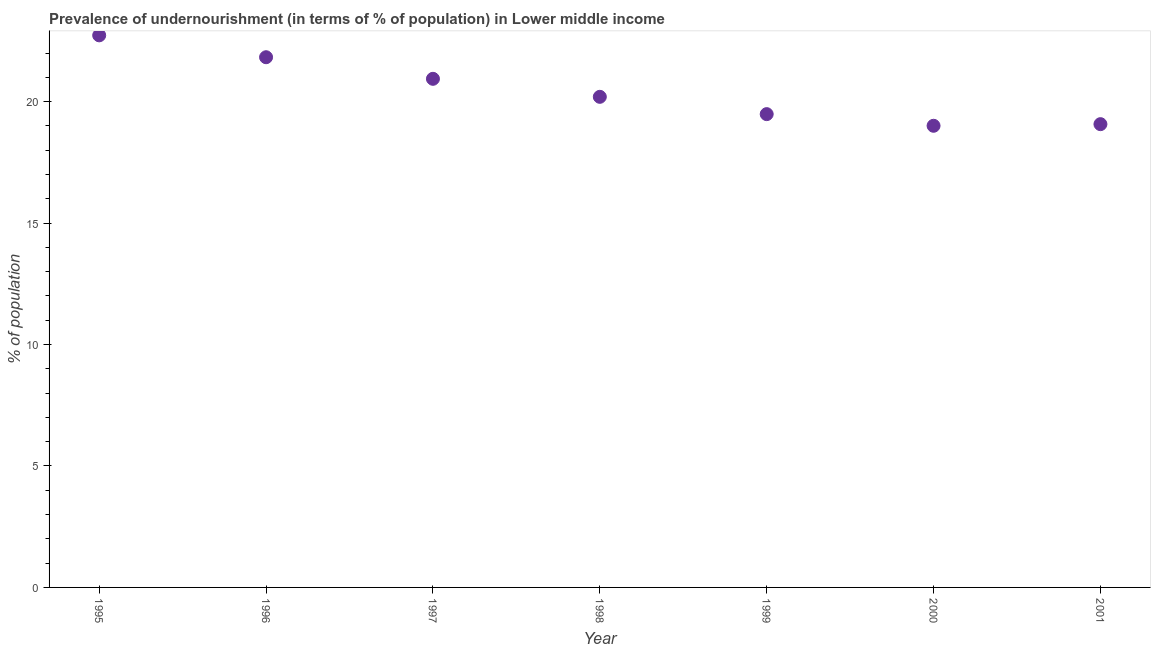What is the percentage of undernourished population in 1999?
Provide a succinct answer. 19.48. Across all years, what is the maximum percentage of undernourished population?
Your answer should be compact. 22.73. Across all years, what is the minimum percentage of undernourished population?
Keep it short and to the point. 19. In which year was the percentage of undernourished population maximum?
Offer a terse response. 1995. What is the sum of the percentage of undernourished population?
Ensure brevity in your answer.  143.25. What is the difference between the percentage of undernourished population in 1995 and 2000?
Your answer should be compact. 3.72. What is the average percentage of undernourished population per year?
Provide a short and direct response. 20.46. What is the median percentage of undernourished population?
Your answer should be very brief. 20.2. In how many years, is the percentage of undernourished population greater than 10 %?
Your response must be concise. 7. Do a majority of the years between 1998 and 2001 (inclusive) have percentage of undernourished population greater than 18 %?
Provide a succinct answer. Yes. What is the ratio of the percentage of undernourished population in 1996 to that in 2000?
Your answer should be very brief. 1.15. What is the difference between the highest and the second highest percentage of undernourished population?
Your answer should be very brief. 0.9. What is the difference between the highest and the lowest percentage of undernourished population?
Your answer should be very brief. 3.72. In how many years, is the percentage of undernourished population greater than the average percentage of undernourished population taken over all years?
Provide a short and direct response. 3. Does the percentage of undernourished population monotonically increase over the years?
Your response must be concise. No. Are the values on the major ticks of Y-axis written in scientific E-notation?
Provide a short and direct response. No. Does the graph contain grids?
Your answer should be very brief. No. What is the title of the graph?
Ensure brevity in your answer.  Prevalence of undernourishment (in terms of % of population) in Lower middle income. What is the label or title of the X-axis?
Your answer should be very brief. Year. What is the label or title of the Y-axis?
Offer a terse response. % of population. What is the % of population in 1995?
Keep it short and to the point. 22.73. What is the % of population in 1996?
Your answer should be compact. 21.83. What is the % of population in 1997?
Offer a terse response. 20.94. What is the % of population in 1998?
Ensure brevity in your answer.  20.2. What is the % of population in 1999?
Make the answer very short. 19.48. What is the % of population in 2000?
Make the answer very short. 19. What is the % of population in 2001?
Ensure brevity in your answer.  19.07. What is the difference between the % of population in 1995 and 1996?
Offer a terse response. 0.9. What is the difference between the % of population in 1995 and 1997?
Make the answer very short. 1.79. What is the difference between the % of population in 1995 and 1998?
Your answer should be very brief. 2.53. What is the difference between the % of population in 1995 and 1999?
Provide a succinct answer. 3.24. What is the difference between the % of population in 1995 and 2000?
Ensure brevity in your answer.  3.72. What is the difference between the % of population in 1995 and 2001?
Offer a terse response. 3.66. What is the difference between the % of population in 1996 and 1997?
Your response must be concise. 0.89. What is the difference between the % of population in 1996 and 1998?
Give a very brief answer. 1.63. What is the difference between the % of population in 1996 and 1999?
Ensure brevity in your answer.  2.34. What is the difference between the % of population in 1996 and 2000?
Offer a very short reply. 2.82. What is the difference between the % of population in 1996 and 2001?
Offer a terse response. 2.76. What is the difference between the % of population in 1997 and 1998?
Ensure brevity in your answer.  0.74. What is the difference between the % of population in 1997 and 1999?
Give a very brief answer. 1.45. What is the difference between the % of population in 1997 and 2000?
Your answer should be very brief. 1.93. What is the difference between the % of population in 1997 and 2001?
Ensure brevity in your answer.  1.87. What is the difference between the % of population in 1998 and 1999?
Your answer should be compact. 0.71. What is the difference between the % of population in 1998 and 2000?
Offer a very short reply. 1.19. What is the difference between the % of population in 1998 and 2001?
Ensure brevity in your answer.  1.13. What is the difference between the % of population in 1999 and 2000?
Offer a terse response. 0.48. What is the difference between the % of population in 1999 and 2001?
Your answer should be compact. 0.41. What is the difference between the % of population in 2000 and 2001?
Your answer should be compact. -0.07. What is the ratio of the % of population in 1995 to that in 1996?
Make the answer very short. 1.04. What is the ratio of the % of population in 1995 to that in 1997?
Your answer should be compact. 1.08. What is the ratio of the % of population in 1995 to that in 1999?
Your answer should be very brief. 1.17. What is the ratio of the % of population in 1995 to that in 2000?
Give a very brief answer. 1.2. What is the ratio of the % of population in 1995 to that in 2001?
Ensure brevity in your answer.  1.19. What is the ratio of the % of population in 1996 to that in 1997?
Your answer should be very brief. 1.04. What is the ratio of the % of population in 1996 to that in 1998?
Your answer should be compact. 1.08. What is the ratio of the % of population in 1996 to that in 1999?
Provide a short and direct response. 1.12. What is the ratio of the % of population in 1996 to that in 2000?
Provide a succinct answer. 1.15. What is the ratio of the % of population in 1996 to that in 2001?
Ensure brevity in your answer.  1.14. What is the ratio of the % of population in 1997 to that in 1999?
Provide a short and direct response. 1.07. What is the ratio of the % of population in 1997 to that in 2000?
Offer a very short reply. 1.1. What is the ratio of the % of population in 1997 to that in 2001?
Offer a terse response. 1.1. What is the ratio of the % of population in 1998 to that in 2000?
Make the answer very short. 1.06. What is the ratio of the % of population in 1998 to that in 2001?
Your answer should be very brief. 1.06. What is the ratio of the % of population in 2000 to that in 2001?
Your answer should be very brief. 1. 